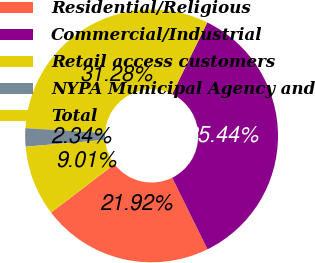Convert chart. <chart><loc_0><loc_0><loc_500><loc_500><pie_chart><fcel>Residential/Religious<fcel>Commercial/Industrial<fcel>Retail access customers<fcel>NYPA Municipal Agency and<fcel>Total<nl><fcel>21.92%<fcel>35.44%<fcel>31.28%<fcel>2.34%<fcel>9.01%<nl></chart> 